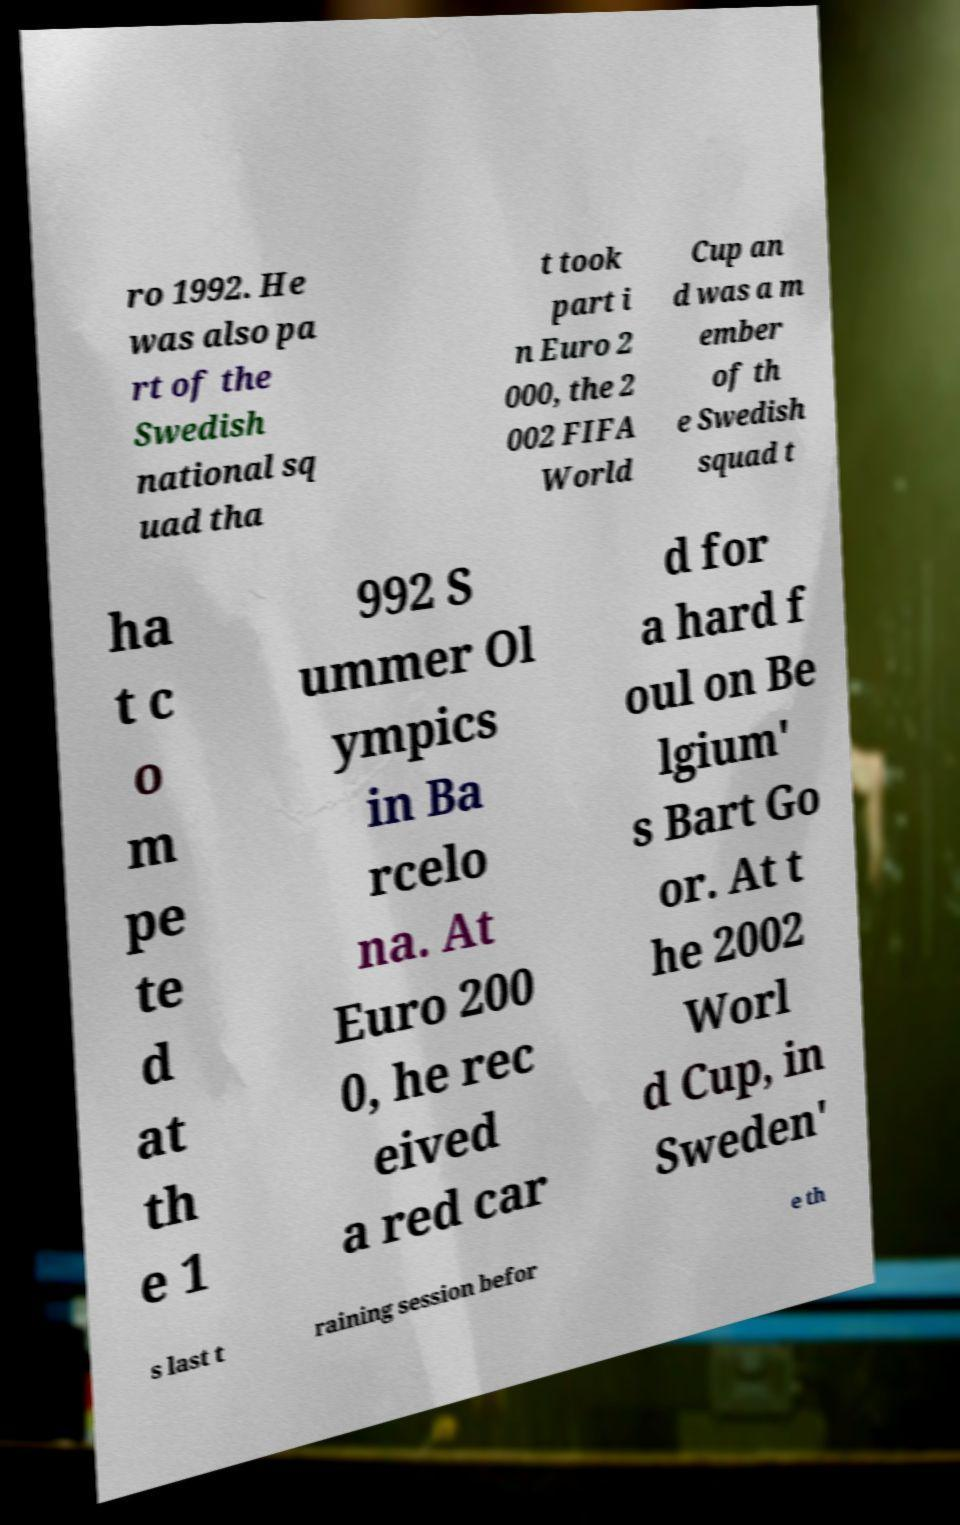Can you read and provide the text displayed in the image?This photo seems to have some interesting text. Can you extract and type it out for me? ro 1992. He was also pa rt of the Swedish national sq uad tha t took part i n Euro 2 000, the 2 002 FIFA World Cup an d was a m ember of th e Swedish squad t ha t c o m pe te d at th e 1 992 S ummer Ol ympics in Ba rcelo na. At Euro 200 0, he rec eived a red car d for a hard f oul on Be lgium' s Bart Go or. At t he 2002 Worl d Cup, in Sweden' s last t raining session befor e th 